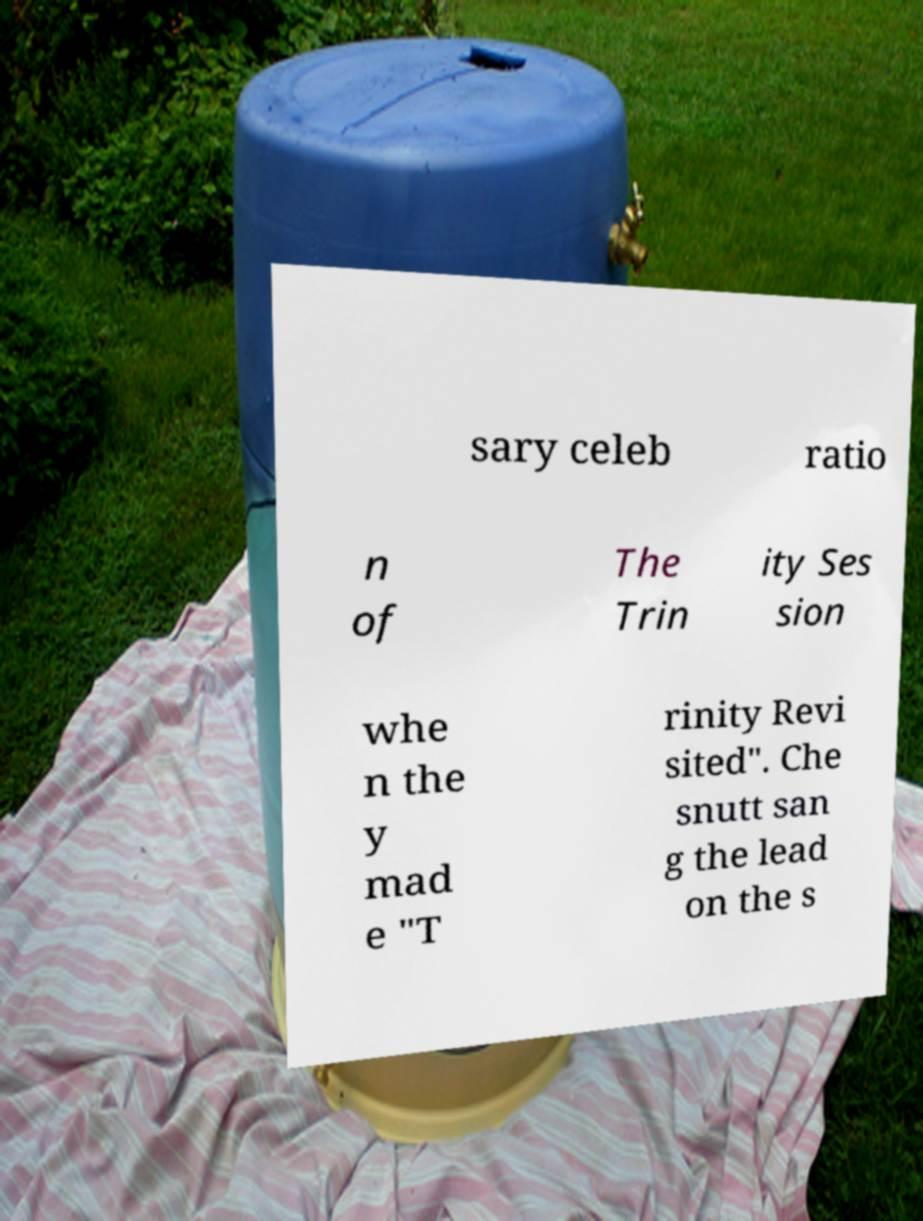Please read and relay the text visible in this image. What does it say? sary celeb ratio n of The Trin ity Ses sion whe n the y mad e "T rinity Revi sited". Che snutt san g the lead on the s 